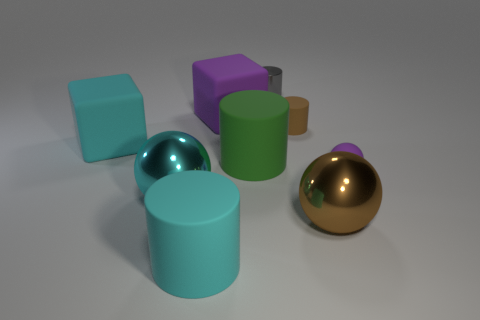Subtract all big green matte cylinders. How many cylinders are left? 3 Subtract all cyan cubes. How many cubes are left? 1 Subtract 1 cylinders. How many cylinders are left? 3 Subtract all cubes. How many objects are left? 7 Subtract all red matte cylinders. Subtract all tiny gray cylinders. How many objects are left? 8 Add 3 large cylinders. How many large cylinders are left? 5 Add 9 blue metal cubes. How many blue metal cubes exist? 9 Subtract 1 brown balls. How many objects are left? 8 Subtract all red blocks. Subtract all brown balls. How many blocks are left? 2 Subtract all cyan blocks. How many green cylinders are left? 1 